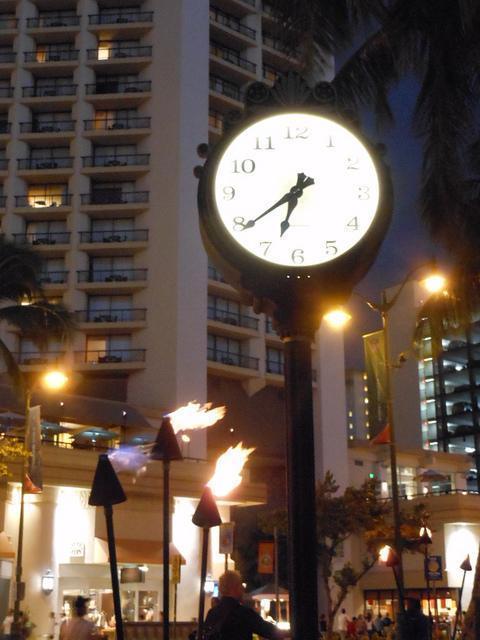In the event of a fire what could be blamed?
Make your selection from the four choices given to correctly answer the question.
Options: Smokers, clock, lights, torch. Torch. 